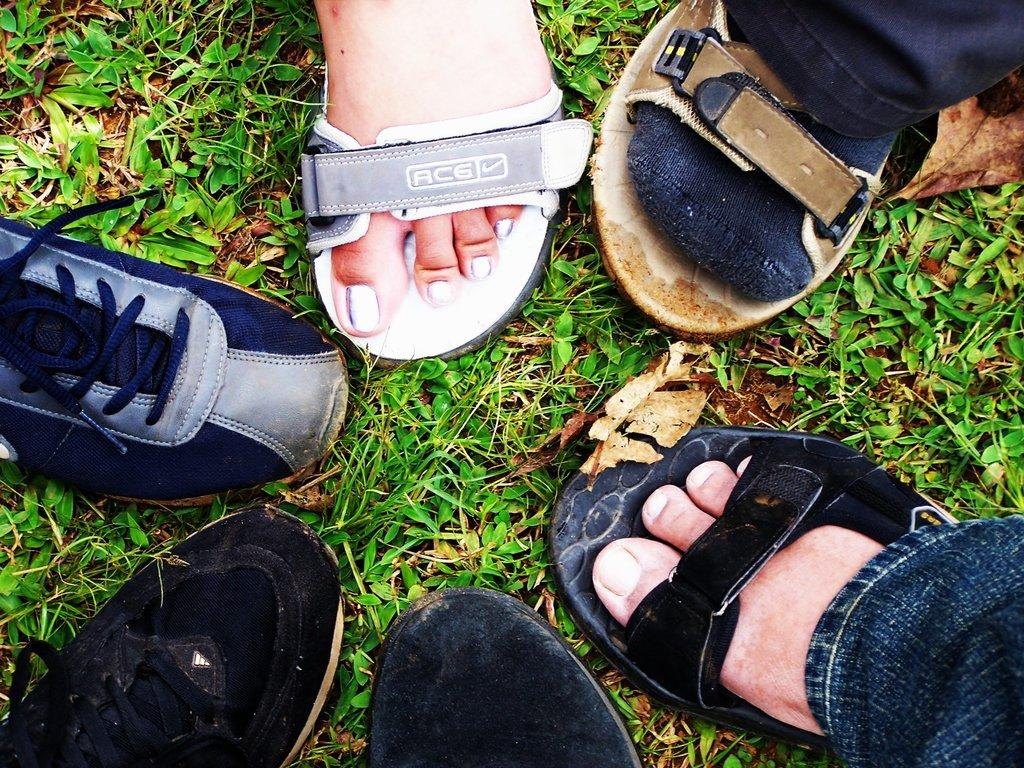What objects are on the left side of the image? There are three shoes on the ground on the left side. What can be seen on the right side of the image? There are three feet on the right side. What is the surface beneath the feet on the right side? The persons wearing the slippers have their feet on the grass on the ground. What type of apples are being handed out as a good-bye gesture in the image? There is no mention of apples or a good-bye gesture in the image; it only features three shoes on the left side and three feet on the right side. 